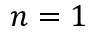<formula> <loc_0><loc_0><loc_500><loc_500>n = 1</formula> 